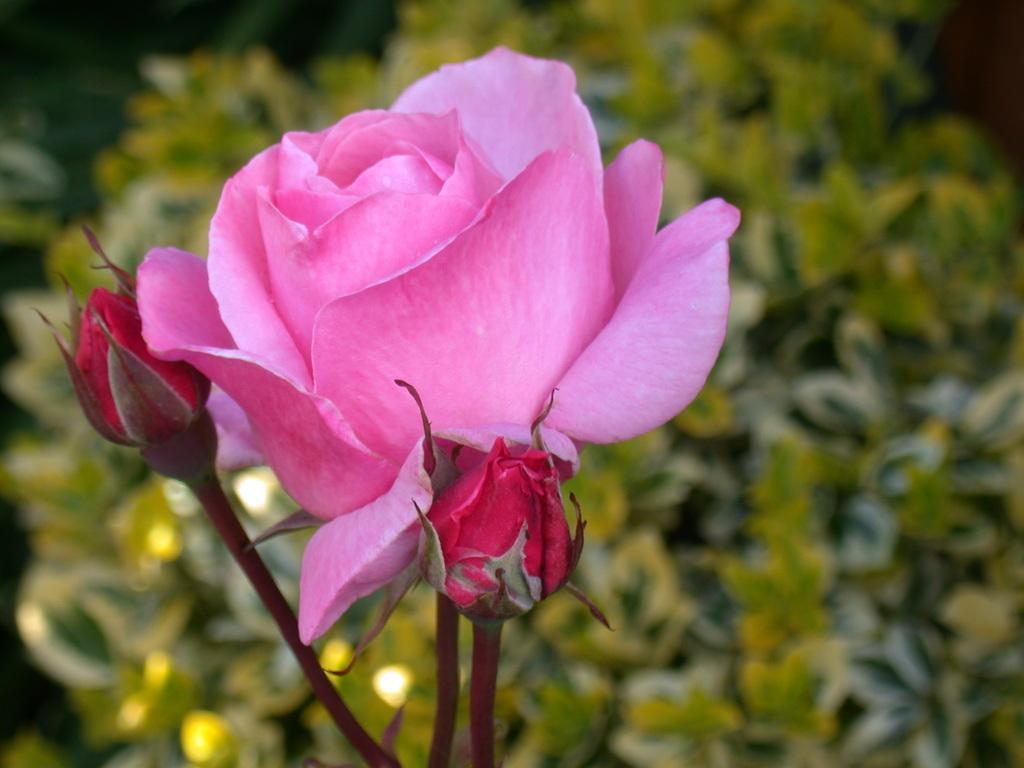Can you describe this image briefly? In this image I can see a rose flower and two buds to the stems. In the background, I can see the leaves. 